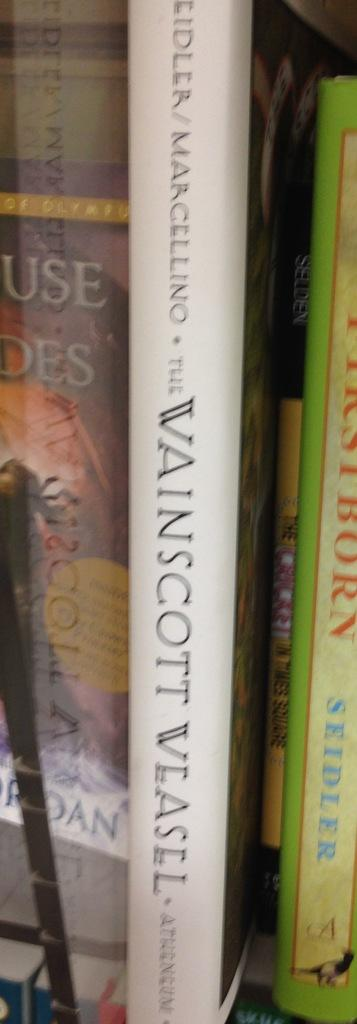<image>
Give a short and clear explanation of the subsequent image. A book by Marcellino sits on a book shelf. 